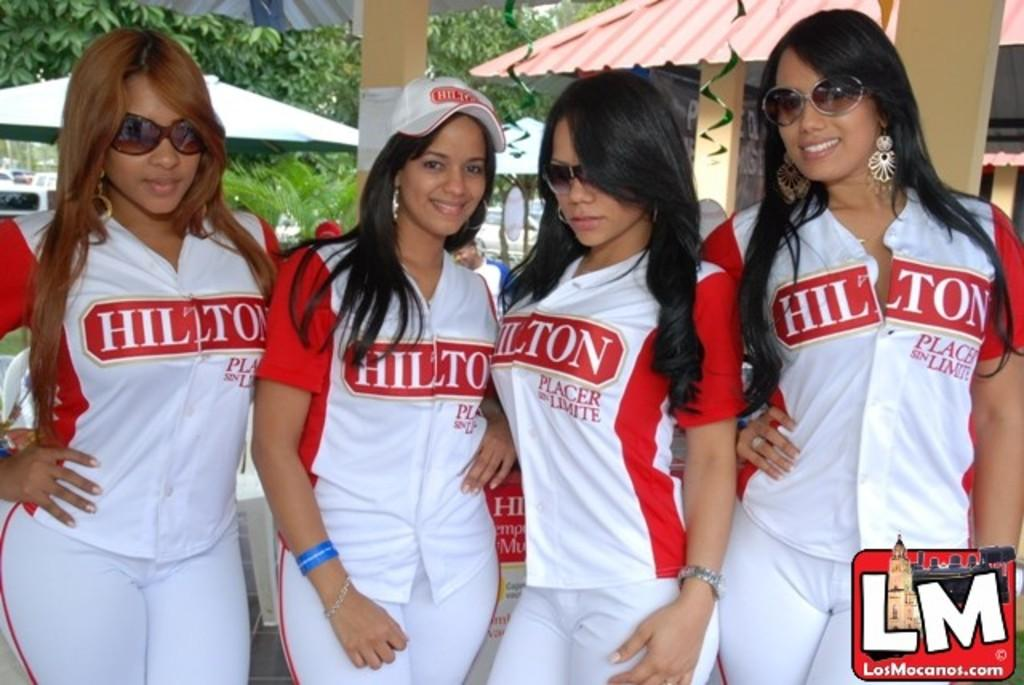<image>
Write a terse but informative summary of the picture. LosMacanos.com LM logo with a Hilton logo on a cap and jersey. 